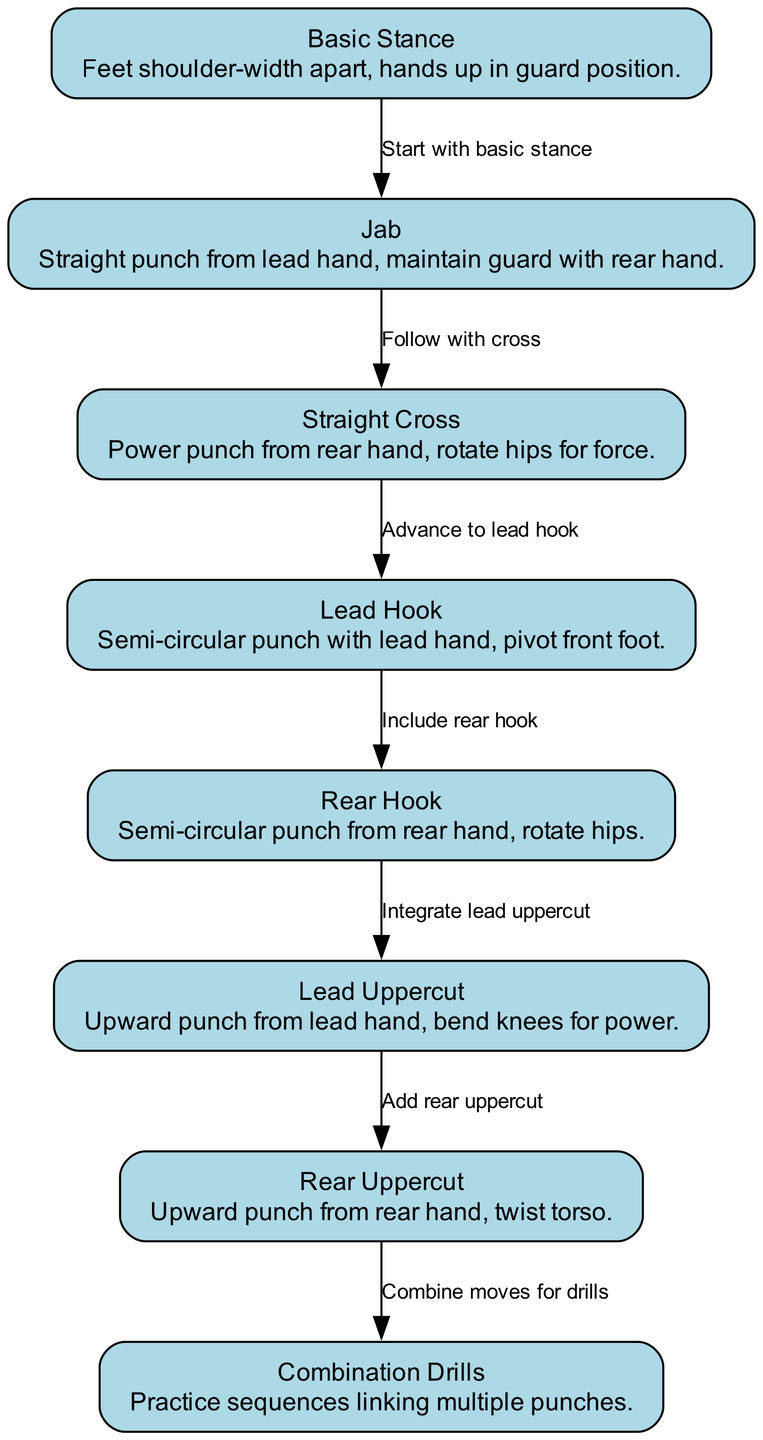What is the first technique in the progression? The diagram shows that the first node is labeled "Basic Stance." It is the starting point indicated in the sequence of boxing techniques.
Answer: Basic Stance How many techniques are shown in the diagram? By counting the nodes present in the diagram, there are a total of eight distinct techniques listed.
Answer: 8 What punch follows the jab? The diagram indicates that after the jab, the next technique is the "Straight Cross" as shown by the edge connecting the two nodes.
Answer: Straight Cross Which technique involves a semi-circular punch with the lead hand? The description under the node for "Lead Hook" specifies that it is a semi-circular punch with the lead hand, making it the answer to the question.
Answer: Lead Hook What two techniques are integrated before moving to the combination drills? To reach the "Combination Drills" node, one must first go through the "Rear Uppercut" and "Add rear uppercut," indicating these two techniques are previous steps in the sequence.
Answer: Lead Uppercut, Rear Uppercut What is the relationship between the "Rear Hook" and "Lead Uppercut"? The diagram has an edge connecting "Rear Hook" to "Lead Uppercut," indicating that one is practiced after the other within the progression of techniques.
Answer: Include rear hook What must a boxer do after mastering the Lead Uppercut? The diagram suggests that after mastering the Lead Uppercut, the next step is to "Add rear uppercut," directing the boxer to integrate that technique.
Answer: Add rear uppercut How is power generated in the Straight Cross? The description for the "Straight Cross" node states that power is generated by rotating the hips, which explains the method of force applied in that punch.
Answer: Rotate hips Which technique utilizes the rear hand for execution? The "Rear Uppercut" node describes that this technique is an upward punch from the rear hand, answering the question based on the information in the diagram.
Answer: Rear Uppercut 